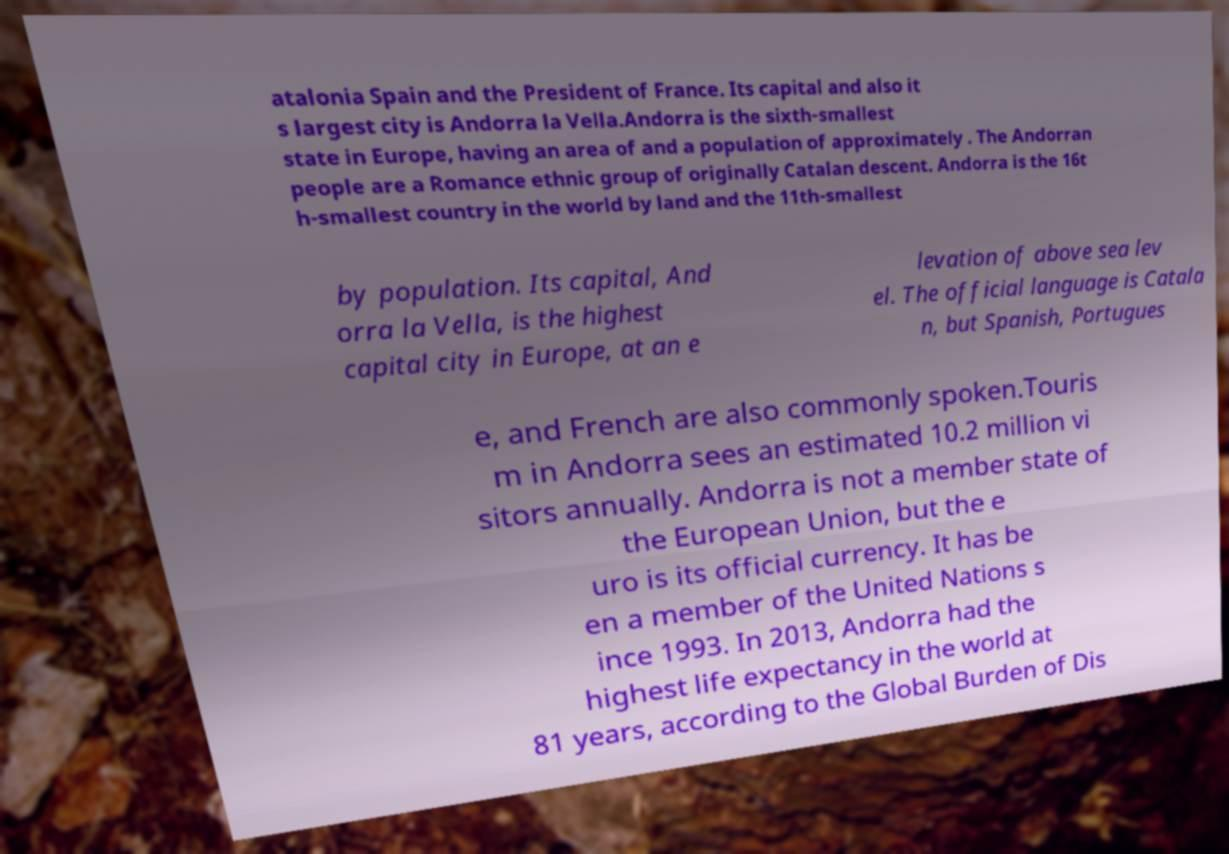Please read and relay the text visible in this image. What does it say? atalonia Spain and the President of France. Its capital and also it s largest city is Andorra la Vella.Andorra is the sixth-smallest state in Europe, having an area of and a population of approximately . The Andorran people are a Romance ethnic group of originally Catalan descent. Andorra is the 16t h-smallest country in the world by land and the 11th-smallest by population. Its capital, And orra la Vella, is the highest capital city in Europe, at an e levation of above sea lev el. The official language is Catala n, but Spanish, Portugues e, and French are also commonly spoken.Touris m in Andorra sees an estimated 10.2 million vi sitors annually. Andorra is not a member state of the European Union, but the e uro is its official currency. It has be en a member of the United Nations s ince 1993. In 2013, Andorra had the highest life expectancy in the world at 81 years, according to the Global Burden of Dis 